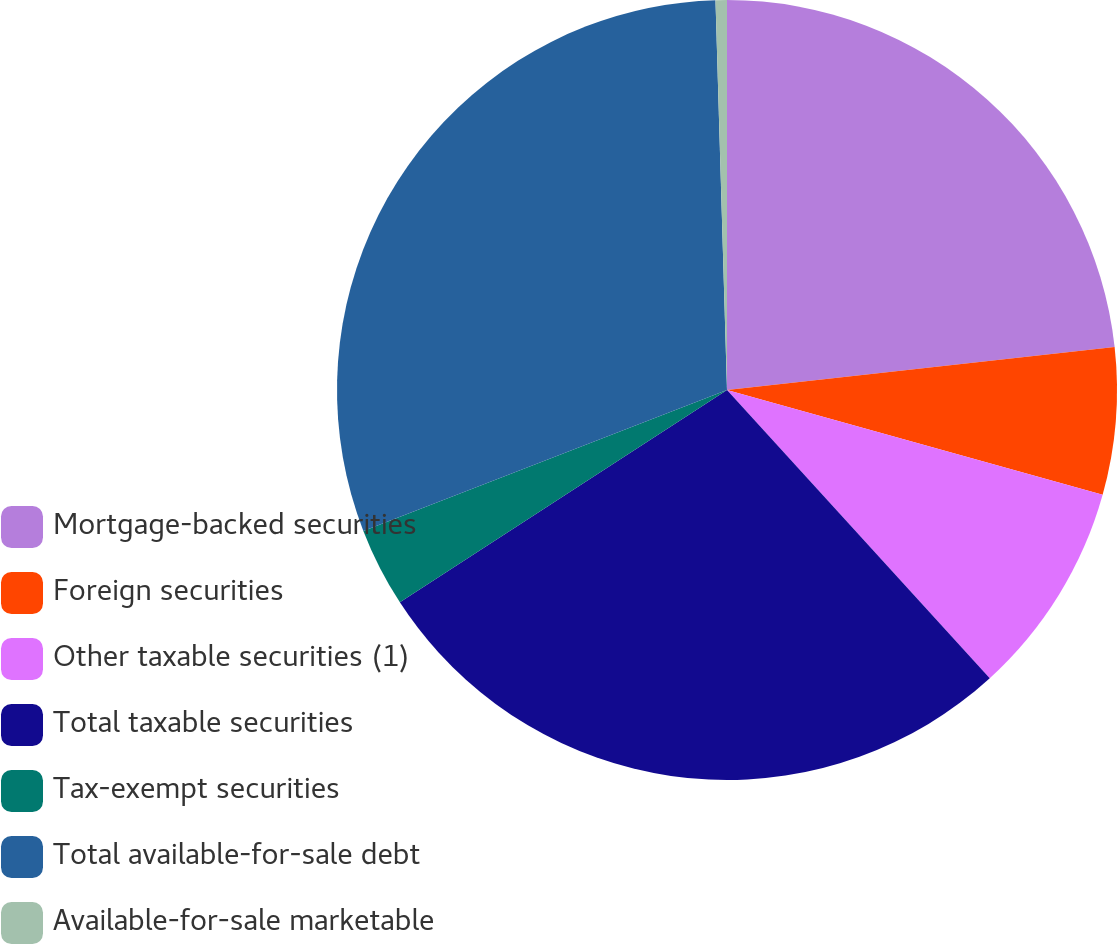Convert chart. <chart><loc_0><loc_0><loc_500><loc_500><pie_chart><fcel>Mortgage-backed securities<fcel>Foreign securities<fcel>Other taxable securities (1)<fcel>Total taxable securities<fcel>Tax-exempt securities<fcel>Total available-for-sale debt<fcel>Available-for-sale marketable<nl><fcel>23.24%<fcel>6.09%<fcel>8.9%<fcel>27.6%<fcel>3.28%<fcel>30.41%<fcel>0.47%<nl></chart> 